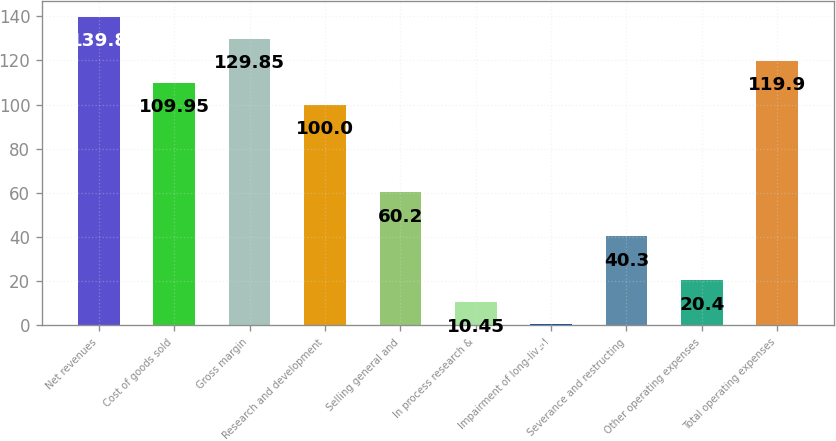Convert chart. <chart><loc_0><loc_0><loc_500><loc_500><bar_chart><fcel>Net revenues<fcel>Cost of goods sold<fcel>Gross margin<fcel>Research and development<fcel>Selling general and<fcel>In process research &<fcel>Impairment of long-lived<fcel>Severance and restructing<fcel>Other operating expenses<fcel>Total operating expenses<nl><fcel>139.8<fcel>109.95<fcel>129.85<fcel>100<fcel>60.2<fcel>10.45<fcel>0.5<fcel>40.3<fcel>20.4<fcel>119.9<nl></chart> 